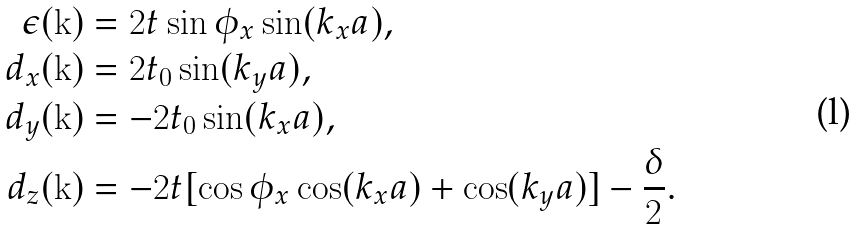Convert formula to latex. <formula><loc_0><loc_0><loc_500><loc_500>\epsilon ( { \mathbf k } ) & = 2 t \sin \phi _ { x } \sin ( k _ { x } a ) , \\ d _ { x } ( { \mathbf k } ) & = 2 t _ { 0 } \sin ( k _ { y } a ) , \\ d _ { y } ( { \mathbf k } ) & = - 2 t _ { 0 } \sin ( k _ { x } a ) , \\ d _ { z } ( { \mathbf k } ) & = - 2 t [ \cos \phi _ { x } \cos ( k _ { x } a ) + \cos ( k _ { y } a ) ] - \frac { \delta } { 2 } .</formula> 